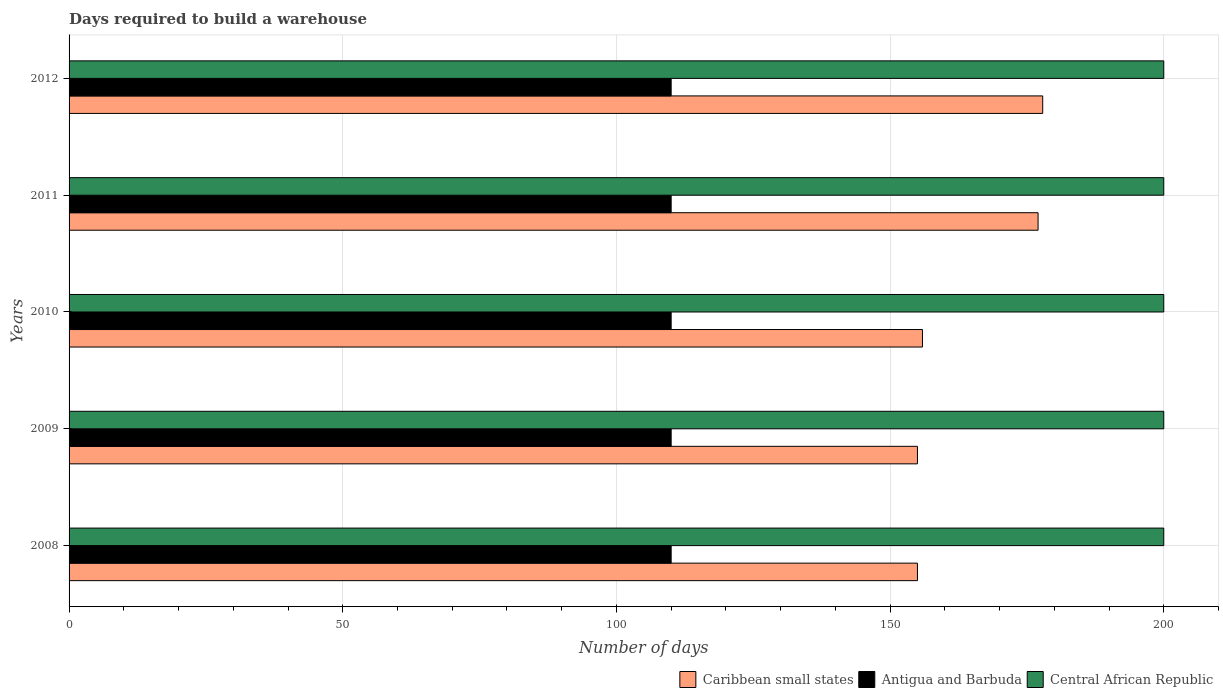How many groups of bars are there?
Your response must be concise. 5. Are the number of bars on each tick of the Y-axis equal?
Your answer should be compact. Yes. How many bars are there on the 2nd tick from the top?
Keep it short and to the point. 3. How many bars are there on the 2nd tick from the bottom?
Give a very brief answer. 3. In how many cases, is the number of bars for a given year not equal to the number of legend labels?
Provide a short and direct response. 0. What is the days required to build a warehouse in in Caribbean small states in 2011?
Give a very brief answer. 177.04. Across all years, what is the maximum days required to build a warehouse in in Central African Republic?
Ensure brevity in your answer.  200. Across all years, what is the minimum days required to build a warehouse in in Central African Republic?
Your answer should be very brief. 200. In which year was the days required to build a warehouse in in Caribbean small states maximum?
Offer a terse response. 2012. In which year was the days required to build a warehouse in in Central African Republic minimum?
Ensure brevity in your answer.  2008. What is the total days required to build a warehouse in in Antigua and Barbuda in the graph?
Provide a short and direct response. 550. What is the difference between the days required to build a warehouse in in Caribbean small states in 2010 and that in 2011?
Make the answer very short. -21.12. What is the difference between the days required to build a warehouse in in Central African Republic in 2010 and the days required to build a warehouse in in Caribbean small states in 2009?
Your answer should be very brief. 45. What is the average days required to build a warehouse in in Caribbean small states per year?
Your response must be concise. 164.17. In the year 2009, what is the difference between the days required to build a warehouse in in Antigua and Barbuda and days required to build a warehouse in in Central African Republic?
Ensure brevity in your answer.  -90. Is the days required to build a warehouse in in Central African Republic in 2009 less than that in 2010?
Your answer should be very brief. No. Is the difference between the days required to build a warehouse in in Antigua and Barbuda in 2011 and 2012 greater than the difference between the days required to build a warehouse in in Central African Republic in 2011 and 2012?
Make the answer very short. No. What is the difference between the highest and the second highest days required to build a warehouse in in Caribbean small states?
Provide a succinct answer. 0.85. What is the difference between the highest and the lowest days required to build a warehouse in in Caribbean small states?
Your response must be concise. 22.88. What does the 3rd bar from the top in 2008 represents?
Provide a succinct answer. Caribbean small states. What does the 3rd bar from the bottom in 2009 represents?
Offer a very short reply. Central African Republic. Is it the case that in every year, the sum of the days required to build a warehouse in in Central African Republic and days required to build a warehouse in in Antigua and Barbuda is greater than the days required to build a warehouse in in Caribbean small states?
Make the answer very short. Yes. How many years are there in the graph?
Your answer should be very brief. 5. Are the values on the major ticks of X-axis written in scientific E-notation?
Keep it short and to the point. No. Does the graph contain grids?
Your response must be concise. Yes. Where does the legend appear in the graph?
Offer a terse response. Bottom right. How are the legend labels stacked?
Your response must be concise. Horizontal. What is the title of the graph?
Your response must be concise. Days required to build a warehouse. What is the label or title of the X-axis?
Provide a short and direct response. Number of days. What is the label or title of the Y-axis?
Offer a terse response. Years. What is the Number of days in Caribbean small states in 2008?
Provide a short and direct response. 155. What is the Number of days of Antigua and Barbuda in 2008?
Give a very brief answer. 110. What is the Number of days of Caribbean small states in 2009?
Your response must be concise. 155. What is the Number of days in Antigua and Barbuda in 2009?
Offer a very short reply. 110. What is the Number of days in Caribbean small states in 2010?
Your answer should be very brief. 155.92. What is the Number of days in Antigua and Barbuda in 2010?
Your response must be concise. 110. What is the Number of days in Caribbean small states in 2011?
Your response must be concise. 177.04. What is the Number of days of Antigua and Barbuda in 2011?
Your response must be concise. 110. What is the Number of days in Caribbean small states in 2012?
Offer a terse response. 177.88. What is the Number of days in Antigua and Barbuda in 2012?
Offer a terse response. 110. Across all years, what is the maximum Number of days of Caribbean small states?
Make the answer very short. 177.88. Across all years, what is the maximum Number of days in Antigua and Barbuda?
Your answer should be compact. 110. Across all years, what is the maximum Number of days in Central African Republic?
Give a very brief answer. 200. Across all years, what is the minimum Number of days in Caribbean small states?
Make the answer very short. 155. Across all years, what is the minimum Number of days in Antigua and Barbuda?
Offer a terse response. 110. Across all years, what is the minimum Number of days of Central African Republic?
Offer a very short reply. 200. What is the total Number of days of Caribbean small states in the graph?
Provide a succinct answer. 820.84. What is the total Number of days in Antigua and Barbuda in the graph?
Provide a short and direct response. 550. What is the total Number of days of Central African Republic in the graph?
Keep it short and to the point. 1000. What is the difference between the Number of days of Antigua and Barbuda in 2008 and that in 2009?
Your response must be concise. 0. What is the difference between the Number of days in Central African Republic in 2008 and that in 2009?
Make the answer very short. 0. What is the difference between the Number of days in Caribbean small states in 2008 and that in 2010?
Provide a short and direct response. -0.92. What is the difference between the Number of days in Antigua and Barbuda in 2008 and that in 2010?
Give a very brief answer. 0. What is the difference between the Number of days of Central African Republic in 2008 and that in 2010?
Provide a succinct answer. 0. What is the difference between the Number of days in Caribbean small states in 2008 and that in 2011?
Offer a very short reply. -22.04. What is the difference between the Number of days of Central African Republic in 2008 and that in 2011?
Offer a terse response. 0. What is the difference between the Number of days of Caribbean small states in 2008 and that in 2012?
Ensure brevity in your answer.  -22.88. What is the difference between the Number of days of Antigua and Barbuda in 2008 and that in 2012?
Your response must be concise. 0. What is the difference between the Number of days in Central African Republic in 2008 and that in 2012?
Provide a short and direct response. 0. What is the difference between the Number of days of Caribbean small states in 2009 and that in 2010?
Provide a short and direct response. -0.92. What is the difference between the Number of days of Antigua and Barbuda in 2009 and that in 2010?
Keep it short and to the point. 0. What is the difference between the Number of days of Caribbean small states in 2009 and that in 2011?
Your response must be concise. -22.04. What is the difference between the Number of days of Central African Republic in 2009 and that in 2011?
Provide a short and direct response. 0. What is the difference between the Number of days of Caribbean small states in 2009 and that in 2012?
Provide a succinct answer. -22.88. What is the difference between the Number of days in Antigua and Barbuda in 2009 and that in 2012?
Give a very brief answer. 0. What is the difference between the Number of days in Central African Republic in 2009 and that in 2012?
Offer a very short reply. 0. What is the difference between the Number of days in Caribbean small states in 2010 and that in 2011?
Your answer should be very brief. -21.12. What is the difference between the Number of days of Antigua and Barbuda in 2010 and that in 2011?
Your answer should be very brief. 0. What is the difference between the Number of days in Caribbean small states in 2010 and that in 2012?
Offer a terse response. -21.97. What is the difference between the Number of days in Antigua and Barbuda in 2010 and that in 2012?
Offer a very short reply. 0. What is the difference between the Number of days in Central African Republic in 2010 and that in 2012?
Offer a terse response. 0. What is the difference between the Number of days of Caribbean small states in 2011 and that in 2012?
Offer a terse response. -0.85. What is the difference between the Number of days in Central African Republic in 2011 and that in 2012?
Your answer should be very brief. 0. What is the difference between the Number of days in Caribbean small states in 2008 and the Number of days in Antigua and Barbuda in 2009?
Make the answer very short. 45. What is the difference between the Number of days of Caribbean small states in 2008 and the Number of days of Central African Republic in 2009?
Your answer should be compact. -45. What is the difference between the Number of days of Antigua and Barbuda in 2008 and the Number of days of Central African Republic in 2009?
Your answer should be compact. -90. What is the difference between the Number of days of Caribbean small states in 2008 and the Number of days of Antigua and Barbuda in 2010?
Provide a short and direct response. 45. What is the difference between the Number of days of Caribbean small states in 2008 and the Number of days of Central African Republic in 2010?
Ensure brevity in your answer.  -45. What is the difference between the Number of days in Antigua and Barbuda in 2008 and the Number of days in Central African Republic in 2010?
Offer a very short reply. -90. What is the difference between the Number of days of Caribbean small states in 2008 and the Number of days of Central African Republic in 2011?
Your answer should be compact. -45. What is the difference between the Number of days of Antigua and Barbuda in 2008 and the Number of days of Central African Republic in 2011?
Keep it short and to the point. -90. What is the difference between the Number of days in Caribbean small states in 2008 and the Number of days in Antigua and Barbuda in 2012?
Your response must be concise. 45. What is the difference between the Number of days in Caribbean small states in 2008 and the Number of days in Central African Republic in 2012?
Give a very brief answer. -45. What is the difference between the Number of days in Antigua and Barbuda in 2008 and the Number of days in Central African Republic in 2012?
Ensure brevity in your answer.  -90. What is the difference between the Number of days of Caribbean small states in 2009 and the Number of days of Antigua and Barbuda in 2010?
Give a very brief answer. 45. What is the difference between the Number of days of Caribbean small states in 2009 and the Number of days of Central African Republic in 2010?
Your answer should be very brief. -45. What is the difference between the Number of days in Antigua and Barbuda in 2009 and the Number of days in Central African Republic in 2010?
Make the answer very short. -90. What is the difference between the Number of days of Caribbean small states in 2009 and the Number of days of Central African Republic in 2011?
Your response must be concise. -45. What is the difference between the Number of days of Antigua and Barbuda in 2009 and the Number of days of Central African Republic in 2011?
Your response must be concise. -90. What is the difference between the Number of days of Caribbean small states in 2009 and the Number of days of Central African Republic in 2012?
Provide a short and direct response. -45. What is the difference between the Number of days in Antigua and Barbuda in 2009 and the Number of days in Central African Republic in 2012?
Provide a succinct answer. -90. What is the difference between the Number of days in Caribbean small states in 2010 and the Number of days in Antigua and Barbuda in 2011?
Make the answer very short. 45.92. What is the difference between the Number of days of Caribbean small states in 2010 and the Number of days of Central African Republic in 2011?
Your response must be concise. -44.08. What is the difference between the Number of days of Antigua and Barbuda in 2010 and the Number of days of Central African Republic in 2011?
Your answer should be compact. -90. What is the difference between the Number of days in Caribbean small states in 2010 and the Number of days in Antigua and Barbuda in 2012?
Ensure brevity in your answer.  45.92. What is the difference between the Number of days in Caribbean small states in 2010 and the Number of days in Central African Republic in 2012?
Make the answer very short. -44.08. What is the difference between the Number of days of Antigua and Barbuda in 2010 and the Number of days of Central African Republic in 2012?
Provide a short and direct response. -90. What is the difference between the Number of days in Caribbean small states in 2011 and the Number of days in Antigua and Barbuda in 2012?
Provide a short and direct response. 67.04. What is the difference between the Number of days of Caribbean small states in 2011 and the Number of days of Central African Republic in 2012?
Offer a terse response. -22.96. What is the difference between the Number of days of Antigua and Barbuda in 2011 and the Number of days of Central African Republic in 2012?
Offer a very short reply. -90. What is the average Number of days in Caribbean small states per year?
Make the answer very short. 164.17. What is the average Number of days in Antigua and Barbuda per year?
Your response must be concise. 110. What is the average Number of days of Central African Republic per year?
Make the answer very short. 200. In the year 2008, what is the difference between the Number of days in Caribbean small states and Number of days in Antigua and Barbuda?
Offer a very short reply. 45. In the year 2008, what is the difference between the Number of days in Caribbean small states and Number of days in Central African Republic?
Make the answer very short. -45. In the year 2008, what is the difference between the Number of days in Antigua and Barbuda and Number of days in Central African Republic?
Provide a succinct answer. -90. In the year 2009, what is the difference between the Number of days in Caribbean small states and Number of days in Antigua and Barbuda?
Provide a short and direct response. 45. In the year 2009, what is the difference between the Number of days in Caribbean small states and Number of days in Central African Republic?
Keep it short and to the point. -45. In the year 2009, what is the difference between the Number of days in Antigua and Barbuda and Number of days in Central African Republic?
Provide a short and direct response. -90. In the year 2010, what is the difference between the Number of days in Caribbean small states and Number of days in Antigua and Barbuda?
Ensure brevity in your answer.  45.92. In the year 2010, what is the difference between the Number of days of Caribbean small states and Number of days of Central African Republic?
Provide a succinct answer. -44.08. In the year 2010, what is the difference between the Number of days of Antigua and Barbuda and Number of days of Central African Republic?
Give a very brief answer. -90. In the year 2011, what is the difference between the Number of days in Caribbean small states and Number of days in Antigua and Barbuda?
Your response must be concise. 67.04. In the year 2011, what is the difference between the Number of days in Caribbean small states and Number of days in Central African Republic?
Your answer should be very brief. -22.96. In the year 2011, what is the difference between the Number of days in Antigua and Barbuda and Number of days in Central African Republic?
Offer a very short reply. -90. In the year 2012, what is the difference between the Number of days in Caribbean small states and Number of days in Antigua and Barbuda?
Provide a short and direct response. 67.88. In the year 2012, what is the difference between the Number of days of Caribbean small states and Number of days of Central African Republic?
Your response must be concise. -22.12. In the year 2012, what is the difference between the Number of days in Antigua and Barbuda and Number of days in Central African Republic?
Provide a succinct answer. -90. What is the ratio of the Number of days of Central African Republic in 2008 to that in 2009?
Make the answer very short. 1. What is the ratio of the Number of days in Caribbean small states in 2008 to that in 2010?
Provide a succinct answer. 0.99. What is the ratio of the Number of days of Antigua and Barbuda in 2008 to that in 2010?
Your answer should be very brief. 1. What is the ratio of the Number of days in Central African Republic in 2008 to that in 2010?
Provide a succinct answer. 1. What is the ratio of the Number of days of Caribbean small states in 2008 to that in 2011?
Ensure brevity in your answer.  0.88. What is the ratio of the Number of days of Antigua and Barbuda in 2008 to that in 2011?
Give a very brief answer. 1. What is the ratio of the Number of days in Caribbean small states in 2008 to that in 2012?
Make the answer very short. 0.87. What is the ratio of the Number of days in Caribbean small states in 2009 to that in 2010?
Give a very brief answer. 0.99. What is the ratio of the Number of days in Central African Republic in 2009 to that in 2010?
Offer a terse response. 1. What is the ratio of the Number of days in Caribbean small states in 2009 to that in 2011?
Your answer should be very brief. 0.88. What is the ratio of the Number of days in Antigua and Barbuda in 2009 to that in 2011?
Provide a short and direct response. 1. What is the ratio of the Number of days in Caribbean small states in 2009 to that in 2012?
Make the answer very short. 0.87. What is the ratio of the Number of days in Antigua and Barbuda in 2009 to that in 2012?
Keep it short and to the point. 1. What is the ratio of the Number of days in Central African Republic in 2009 to that in 2012?
Your answer should be compact. 1. What is the ratio of the Number of days of Caribbean small states in 2010 to that in 2011?
Your answer should be very brief. 0.88. What is the ratio of the Number of days of Antigua and Barbuda in 2010 to that in 2011?
Your response must be concise. 1. What is the ratio of the Number of days of Central African Republic in 2010 to that in 2011?
Ensure brevity in your answer.  1. What is the ratio of the Number of days of Caribbean small states in 2010 to that in 2012?
Offer a terse response. 0.88. What is the ratio of the Number of days of Antigua and Barbuda in 2010 to that in 2012?
Your response must be concise. 1. What is the ratio of the Number of days in Caribbean small states in 2011 to that in 2012?
Make the answer very short. 1. What is the ratio of the Number of days of Antigua and Barbuda in 2011 to that in 2012?
Provide a succinct answer. 1. What is the ratio of the Number of days in Central African Republic in 2011 to that in 2012?
Make the answer very short. 1. What is the difference between the highest and the second highest Number of days of Caribbean small states?
Ensure brevity in your answer.  0.85. What is the difference between the highest and the second highest Number of days in Antigua and Barbuda?
Offer a very short reply. 0. What is the difference between the highest and the lowest Number of days of Caribbean small states?
Provide a short and direct response. 22.88. What is the difference between the highest and the lowest Number of days in Antigua and Barbuda?
Keep it short and to the point. 0. What is the difference between the highest and the lowest Number of days of Central African Republic?
Keep it short and to the point. 0. 